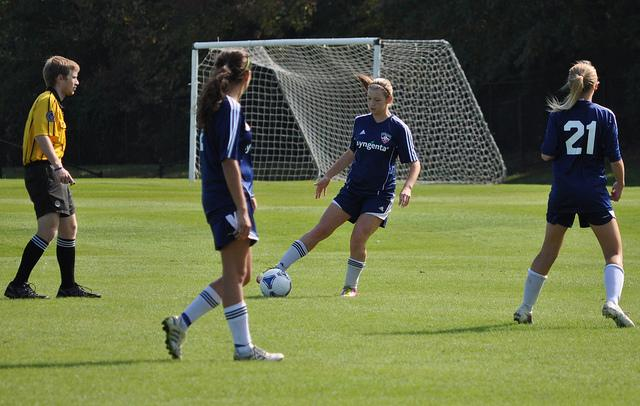Who will try to get the ball from the person who touches it?

Choices:
A) yellow person
B) 21
C) coach
D) referee yellow person 